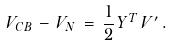<formula> <loc_0><loc_0><loc_500><loc_500>V _ { C B } \, - \, V _ { N } \, = \, \frac { 1 } { 2 } \, Y ^ { T } \, V ^ { \prime } \, .</formula> 